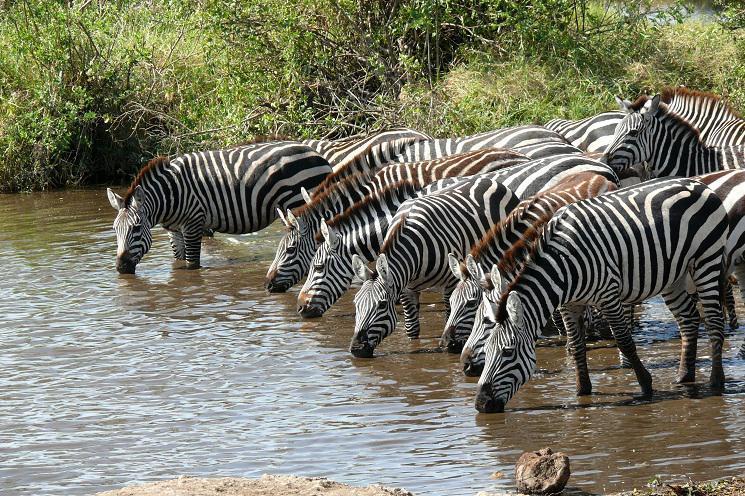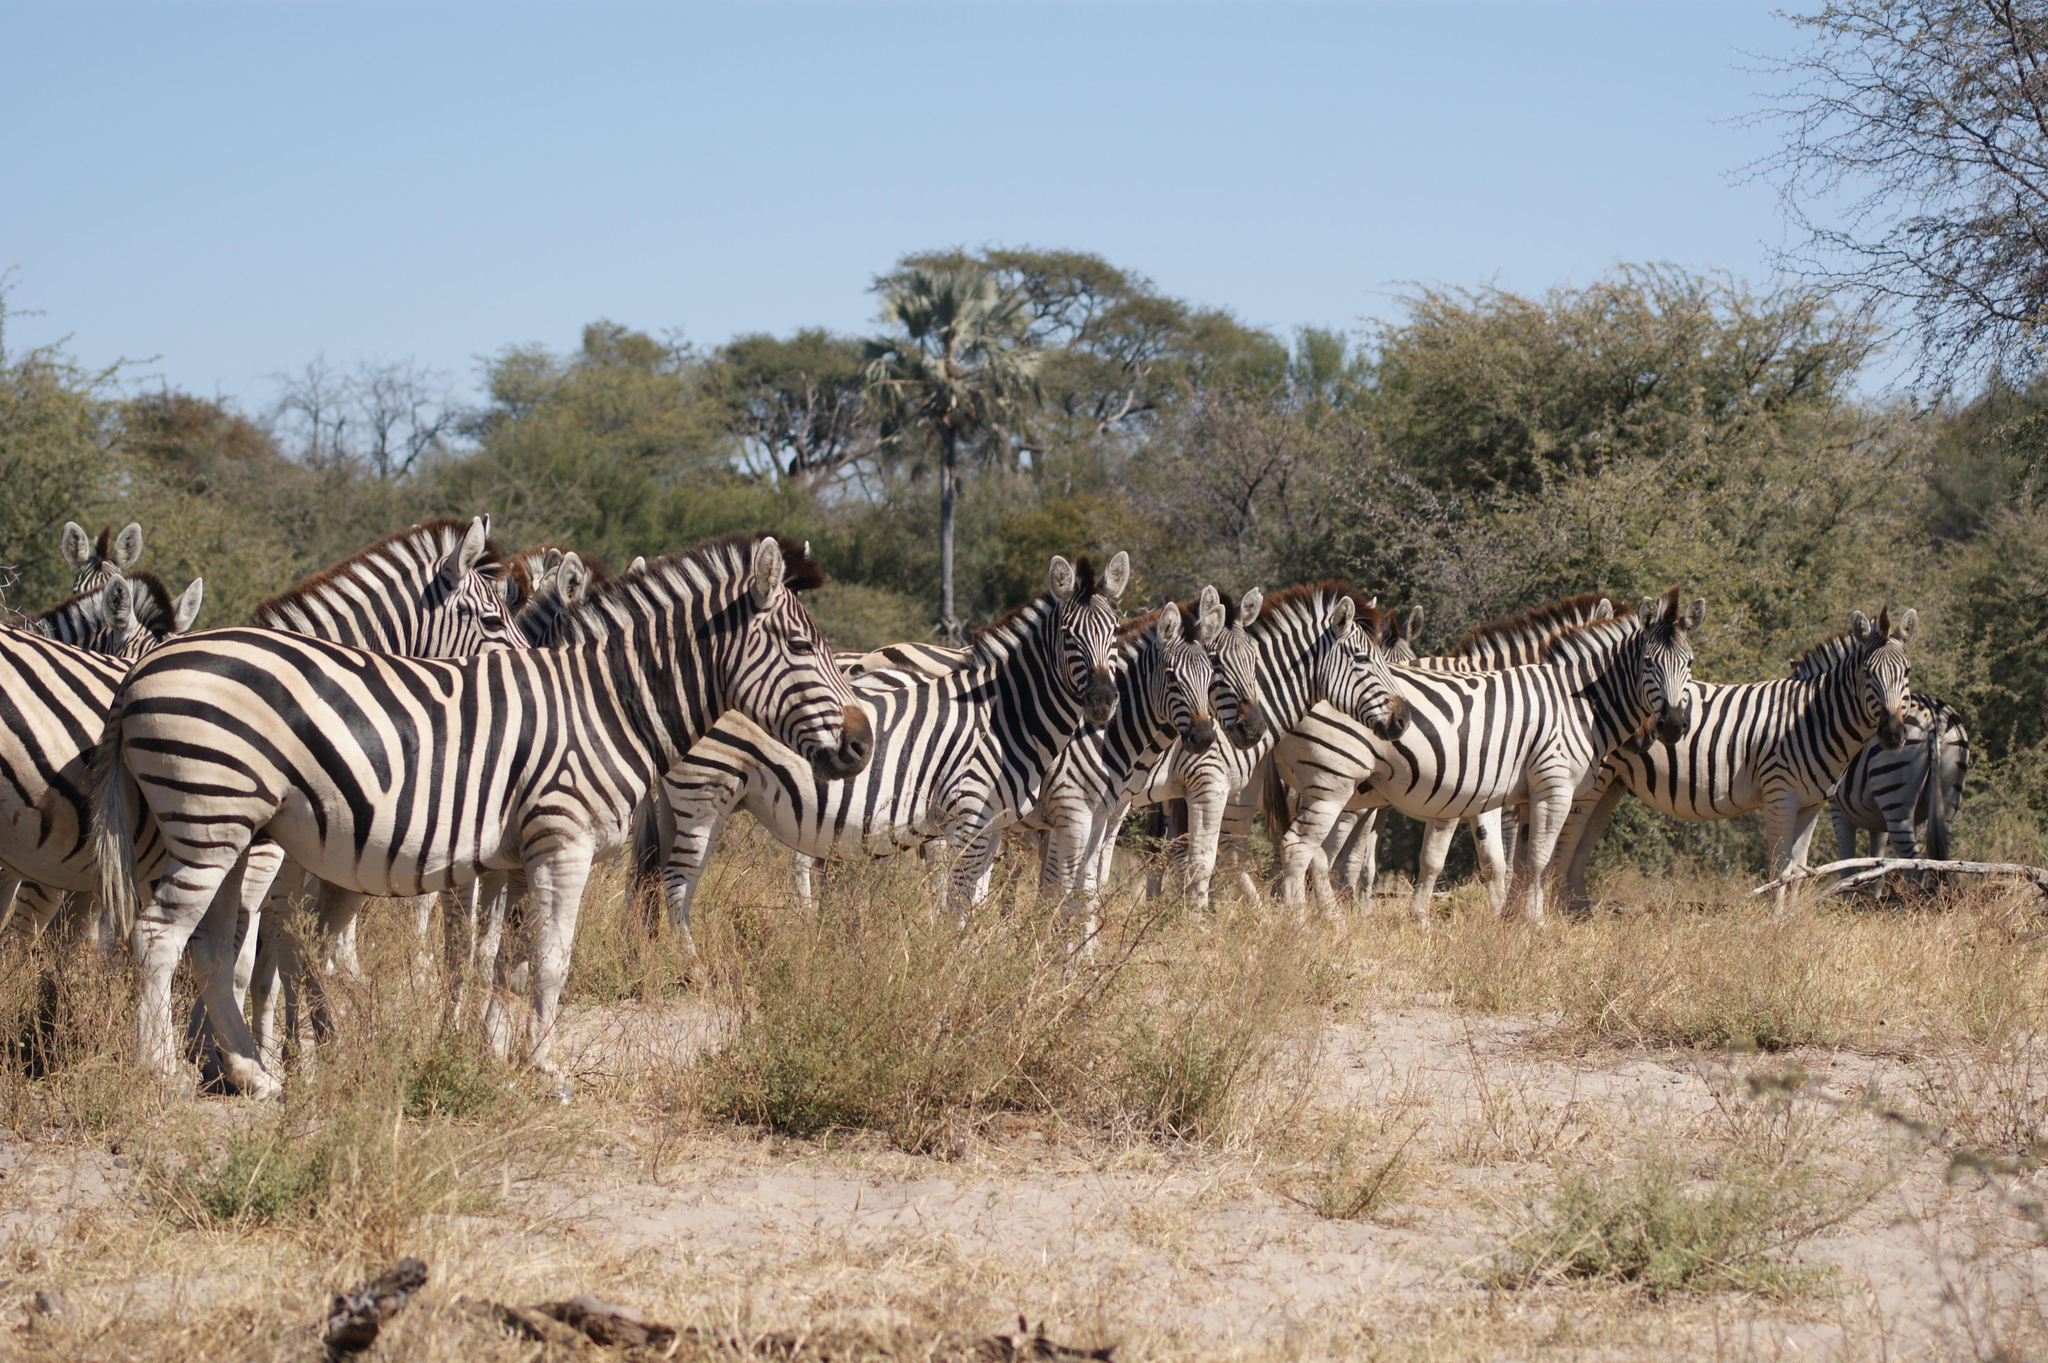The first image is the image on the left, the second image is the image on the right. Examine the images to the left and right. Is the description "there are zebras standing in a row drinking water" accurate? Answer yes or no. Yes. The first image is the image on the left, the second image is the image on the right. Examine the images to the left and right. Is the description "One image shows leftward-facing zebras lined up with bent heads drinking from water they are standing in." accurate? Answer yes or no. Yes. 